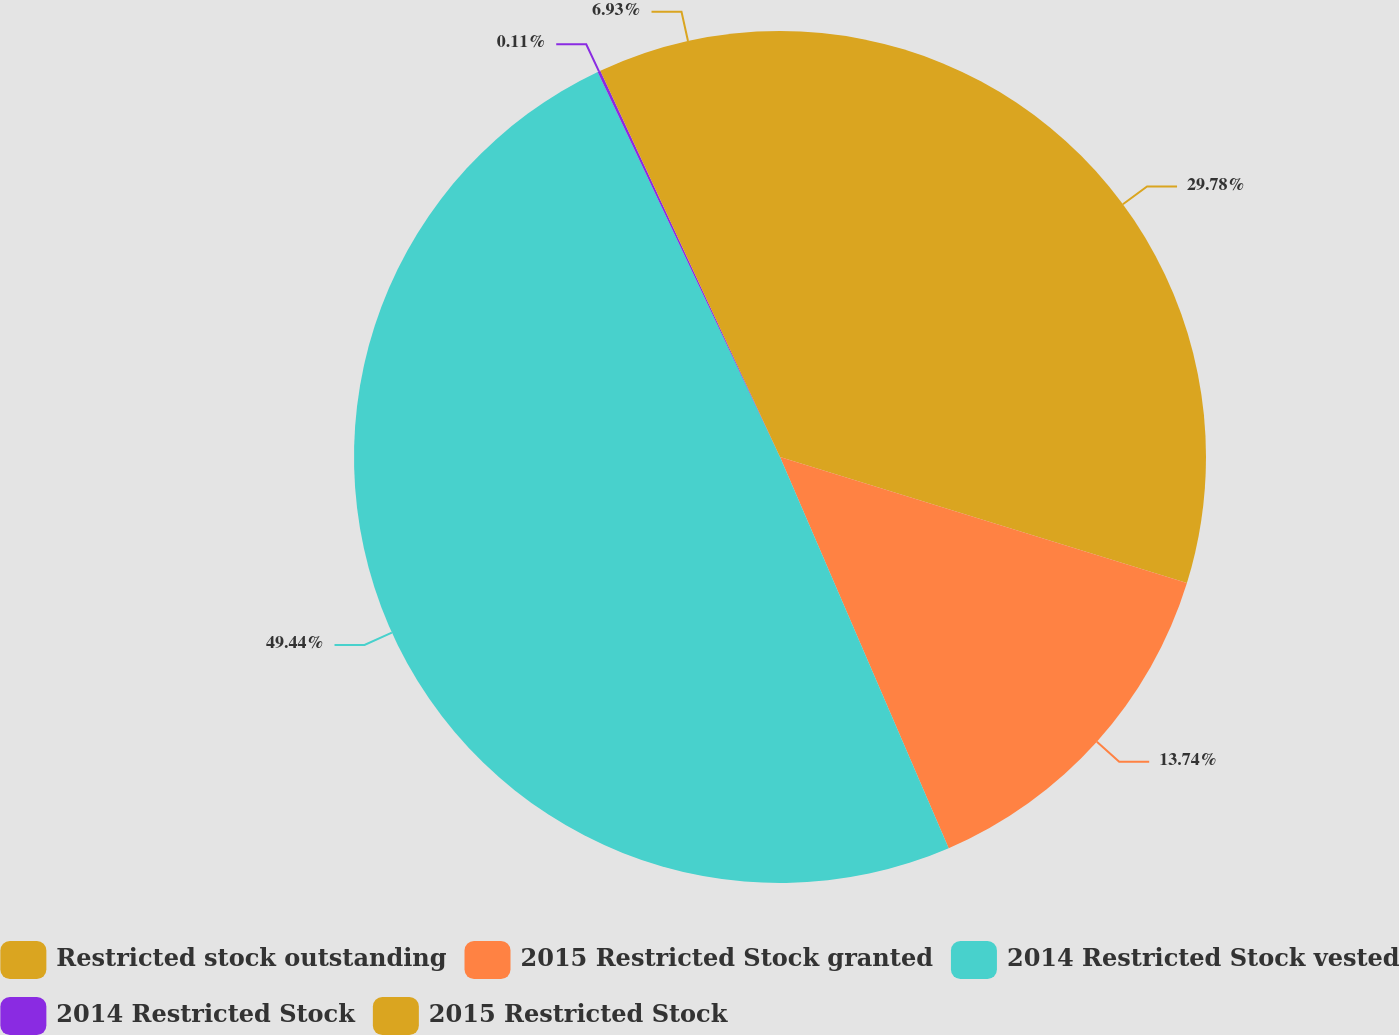<chart> <loc_0><loc_0><loc_500><loc_500><pie_chart><fcel>Restricted stock outstanding<fcel>2015 Restricted Stock granted<fcel>2014 Restricted Stock vested<fcel>2014 Restricted Stock<fcel>2015 Restricted Stock<nl><fcel>29.78%<fcel>13.74%<fcel>49.44%<fcel>0.11%<fcel>6.93%<nl></chart> 